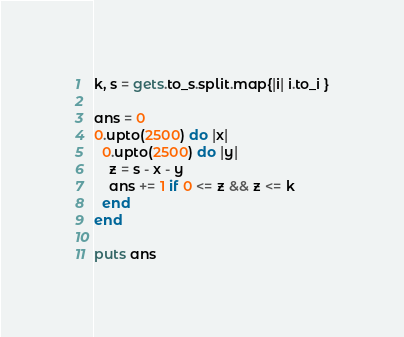<code> <loc_0><loc_0><loc_500><loc_500><_Crystal_>k, s = gets.to_s.split.map{|i| i.to_i }

ans = 0
0.upto(2500) do |x|
  0.upto(2500) do |y|
    z = s - x - y
    ans += 1 if 0 <= z && z <= k
  end
end

puts ans</code> 